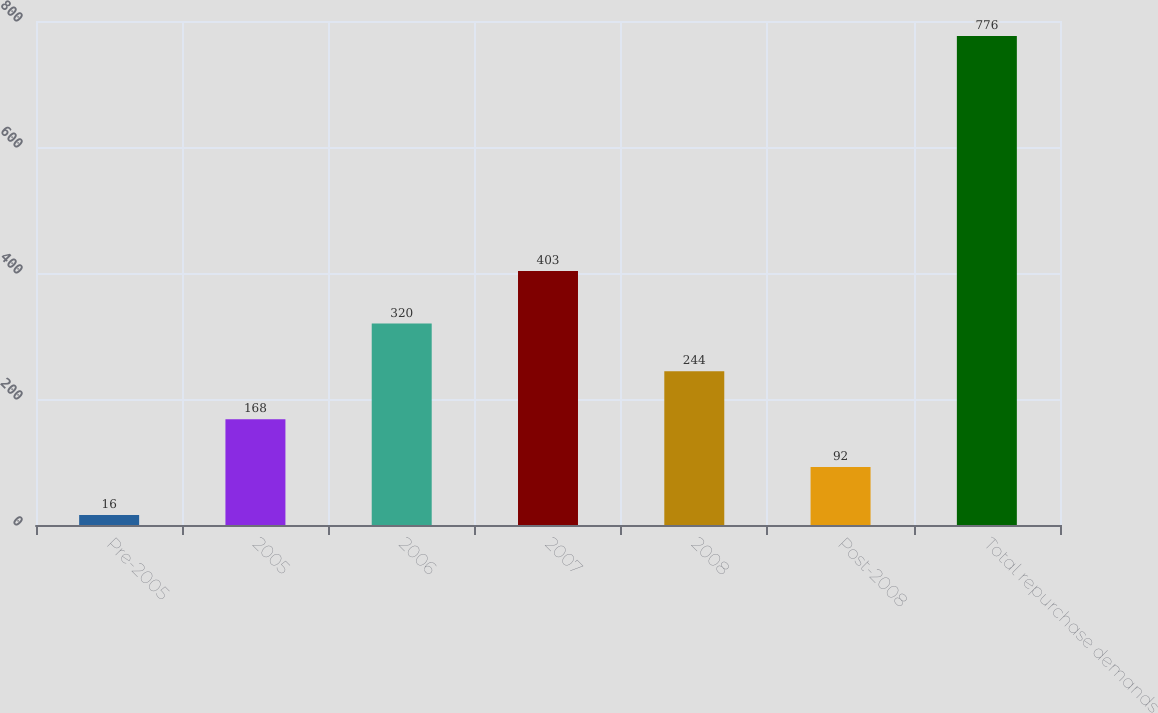Convert chart to OTSL. <chart><loc_0><loc_0><loc_500><loc_500><bar_chart><fcel>Pre-2005<fcel>2005<fcel>2006<fcel>2007<fcel>2008<fcel>Post-2008<fcel>Total repurchase demands<nl><fcel>16<fcel>168<fcel>320<fcel>403<fcel>244<fcel>92<fcel>776<nl></chart> 